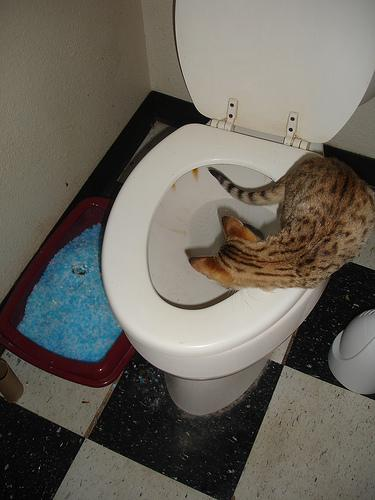Describe the main subject and objects surrounding it in the image. A spotted brown and white cat is laying on a white toilet with its seat up, looking into the bowl with rust stains; nearby is a red litter box with blue sand on a black-and-white checkered floor. Mention the most remarkable features of the objects present in the image. Brown spotted cat on a toilet with seat up, tail inside the bowl; red cat litter container with blue litter; and black-and-white checkered floor. Create a sentence that vividly describes the main action taking place in the image. A curious brown and white spotted cat intently peers into a toilet bowl with rust stains while laying comfortably atop the open seat, its tail dipping right into the water. Describe the interaction between the main subject and its environment. A brown cat with white spots is lying on an open white toilet seat, partially inside the bowl with its tail, while being surrounded by other bathroom elements such as a toilet brush and a litter box with blue sand. List the main elements and objects in the picture. cat on toilet seat, toilet lid up, toilet brush, empty toilet paper roll, black and white tiled floor, red cat box with blue sand, rust stain in toilet bowl Provide a brief description of the main scene in the image. A large brown cat is laying on an open white toilet seat, looking into the toilet bowl with its tail inside, while a red litter box with blue sand sits nearby. Describe the setting of the image in detail. The image shows an indoor tiled bathroom consisting of a white toilet with the seat flipped up, next to a red litter box holding shiny blue kitty litter, with a black and white checkered linoleum floor. Narrate the image as if it is a scene from a story. In a household bathroom, a curious brown spotted cat lay on an open toilet seat with its tail in the bowl, seemingly engrossed in the sight of rust stains, while a burgundy litter box filled with blue sand stood close by. Explain the relationship between the various objects and elements in the image. A cat explores the toilet bowl while laying on the open seat, with the rust stains inside the bowl visible; a red litter box with blue sand is placed nearby on the black and white checkered floor. Write down the colors and characteristics of the main objects in the scene. Brown cat with white spots, white toilet with rust stains and open seat, red litter box with blue sand, black and white checkered floor, and empty toilet paper roll. 